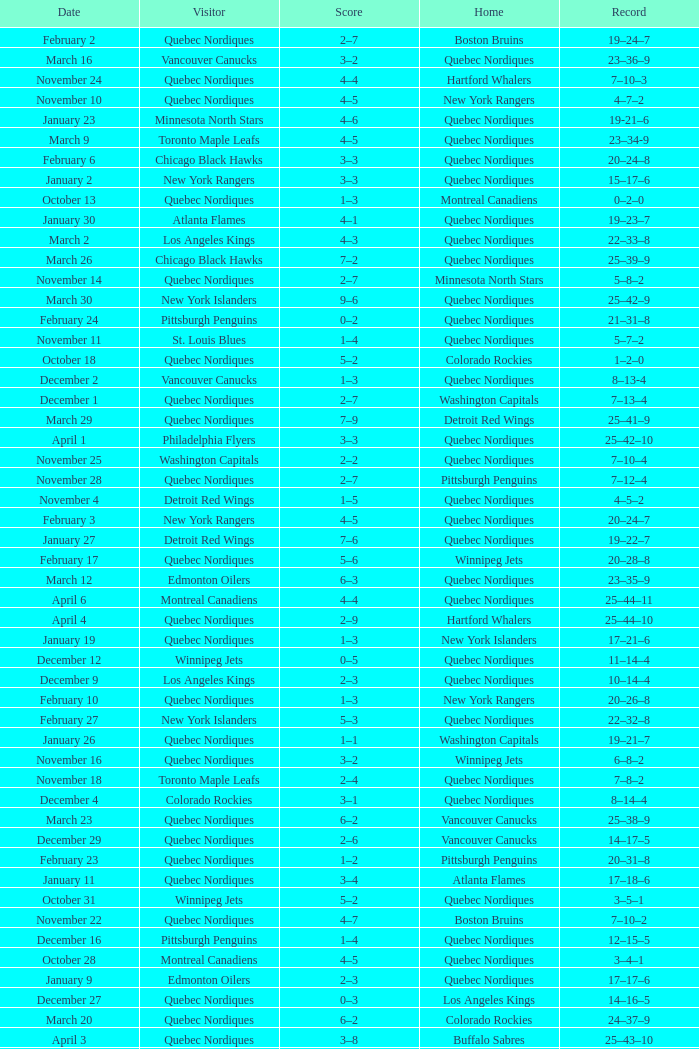Which Home has a Record of 11–14–4? Quebec Nordiques. 